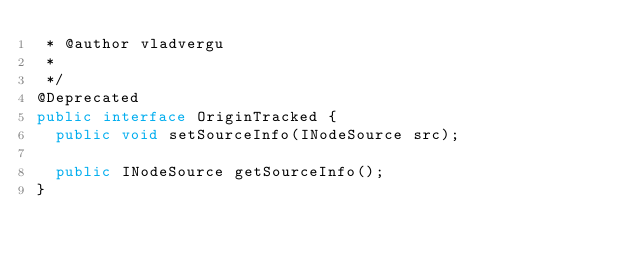Convert code to text. <code><loc_0><loc_0><loc_500><loc_500><_Java_> * @author vladvergu
 *
 */
@Deprecated
public interface OriginTracked {
	public void setSourceInfo(INodeSource src);

	public INodeSource getSourceInfo();
}
</code> 